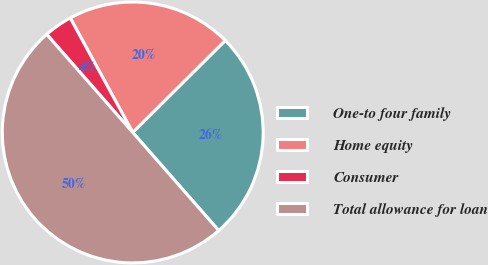<chart> <loc_0><loc_0><loc_500><loc_500><pie_chart><fcel>One-to four family<fcel>Home equity<fcel>Consumer<fcel>Total allowance for loan<nl><fcel>26.0%<fcel>20.5%<fcel>3.5%<fcel>50.0%<nl></chart> 